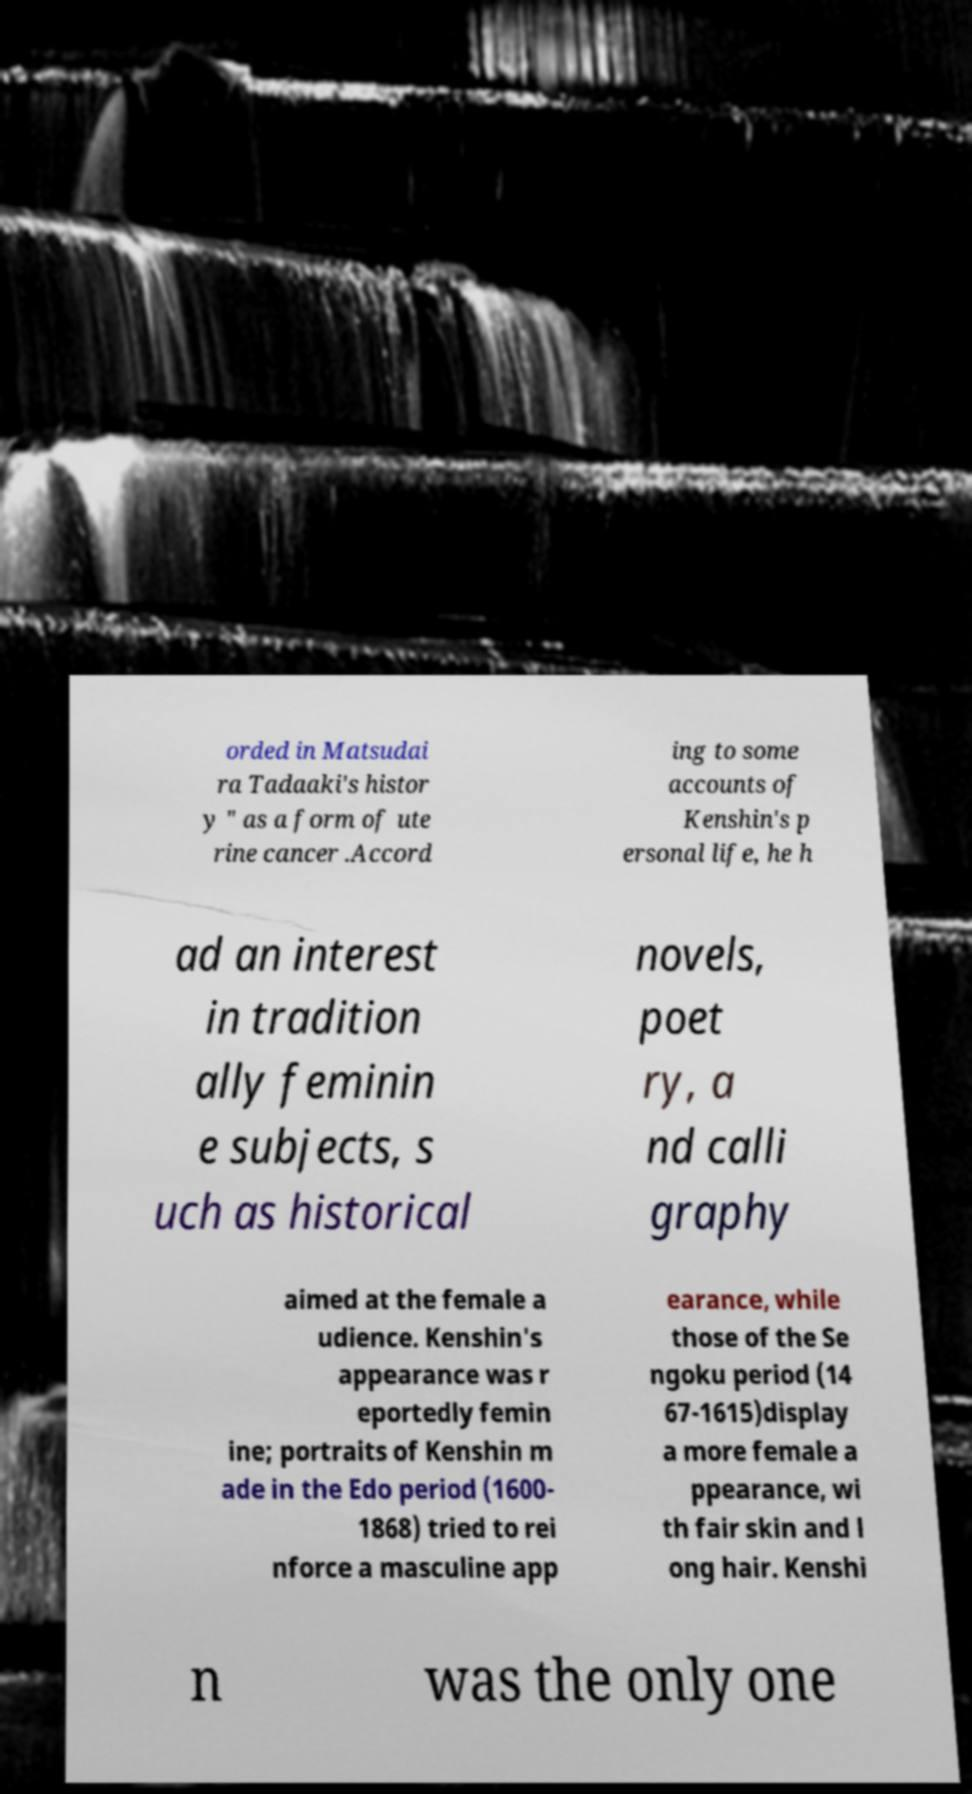There's text embedded in this image that I need extracted. Can you transcribe it verbatim? orded in Matsudai ra Tadaaki's histor y " as a form of ute rine cancer .Accord ing to some accounts of Kenshin's p ersonal life, he h ad an interest in tradition ally feminin e subjects, s uch as historical novels, poet ry, a nd calli graphy aimed at the female a udience. Kenshin's appearance was r eportedly femin ine; portraits of Kenshin m ade in the Edo period (1600- 1868) tried to rei nforce a masculine app earance, while those of the Se ngoku period (14 67-1615)display a more female a ppearance, wi th fair skin and l ong hair. Kenshi n was the only one 